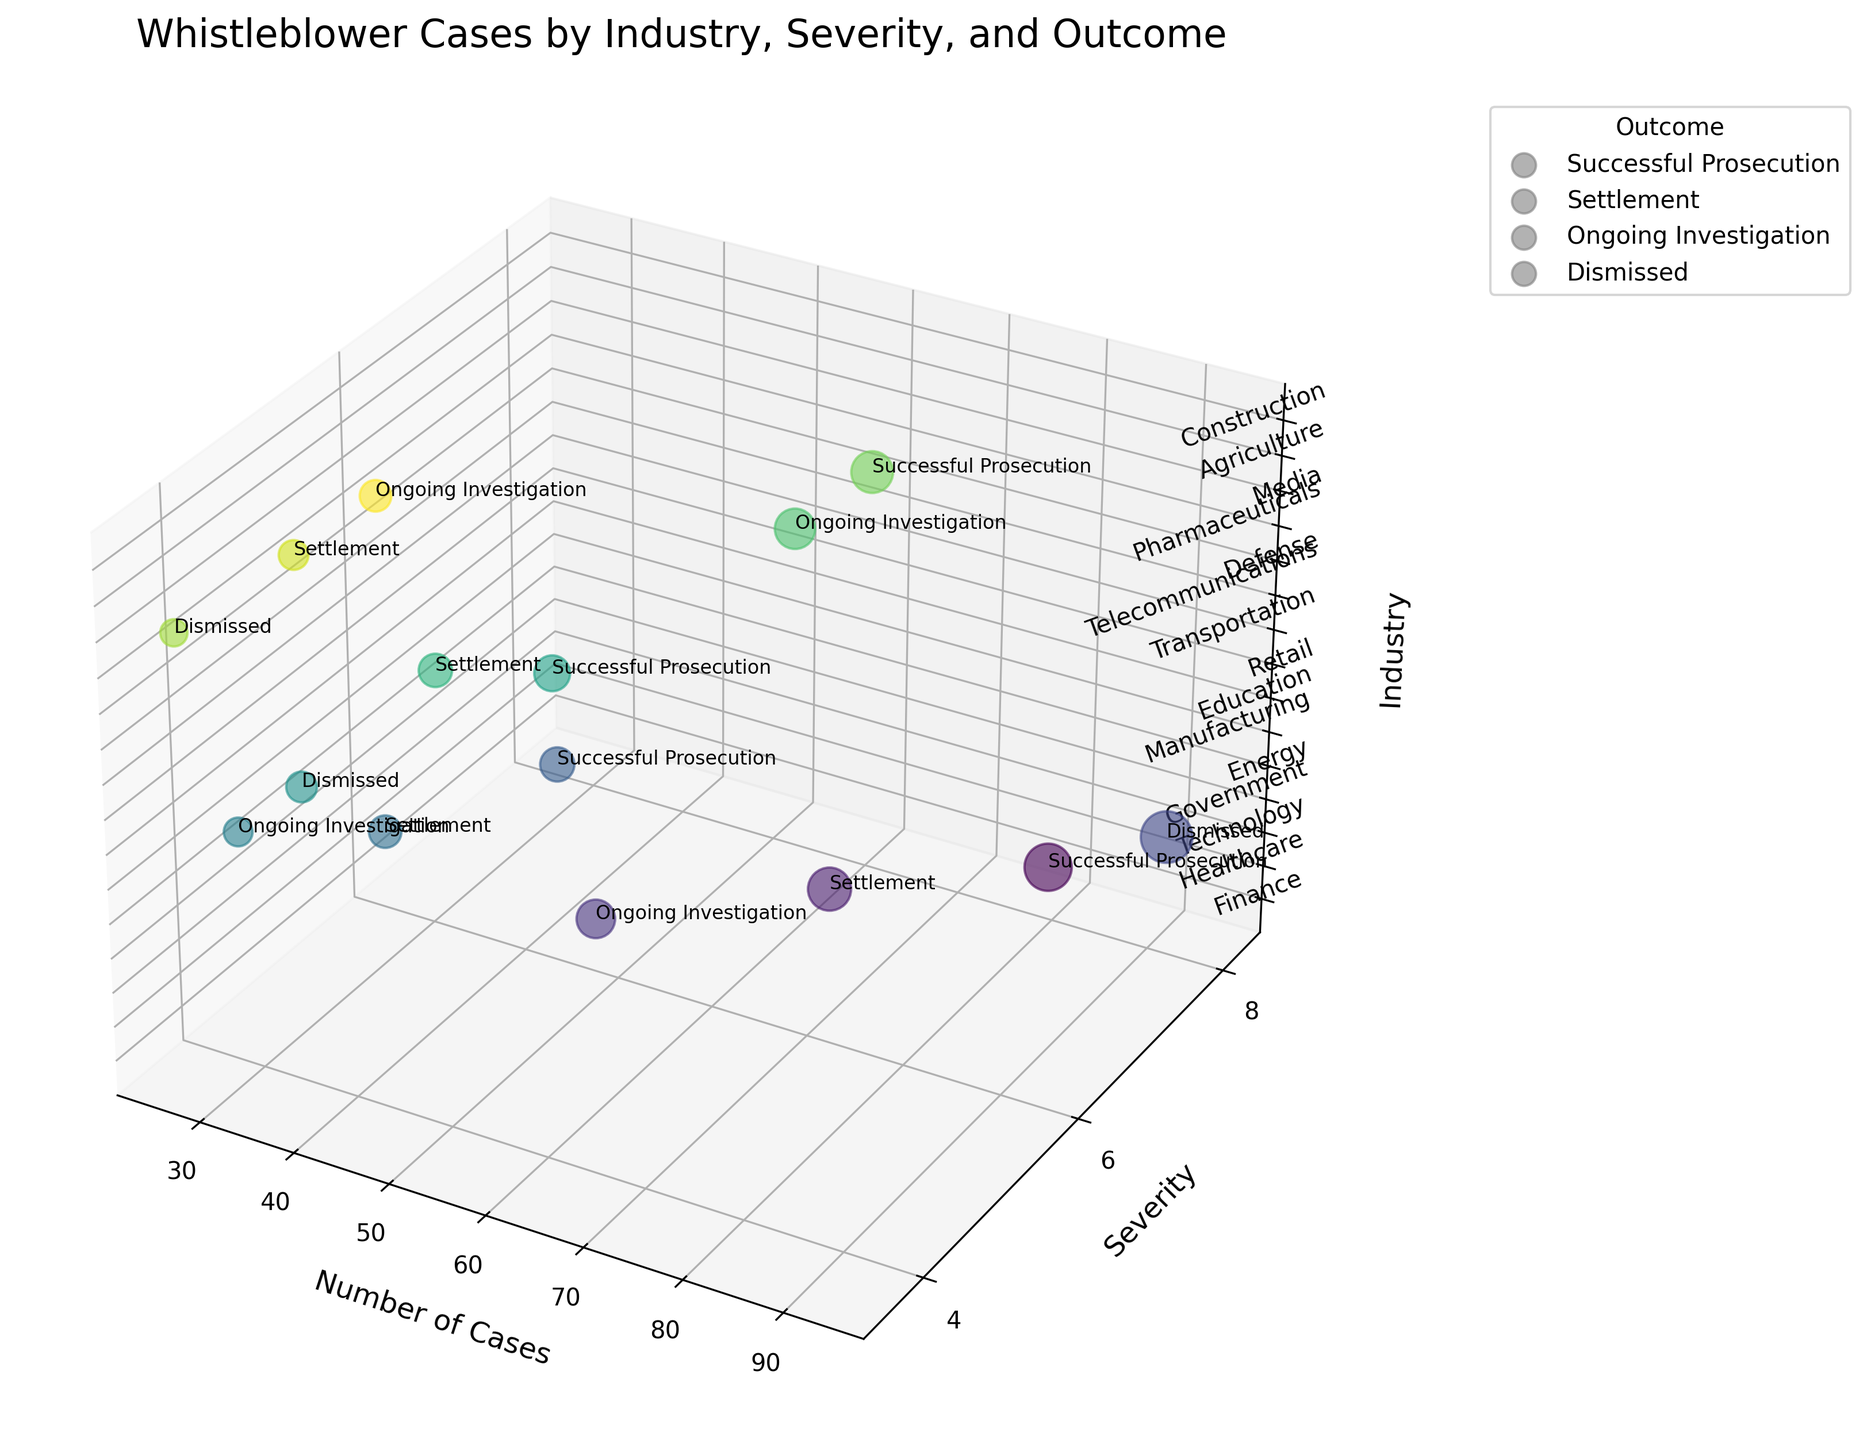What's the title of the figure? The title is displayed at the top of the chart in larger font size
Answer: Whistleblower Cases by Industry, Severity, and Outcome What are the labels of the axes in the figure? The labels of the axes are located next to the axes themselves, indicating what each axis represents
Answer: Number of Cases, Severity, Industry What's the color scheme used for the bubbles in the figure? The colors of the bubbles are derived from the 'viridis' colormap used, which ranges from dark blue to yellow-green
Answer: viridis How many industries are represented in the chart? The number of industries corresponds to the number of bubbles and z-axis ticks in the chart
Answer: 15 Which industry sector has the highest number of cases? The bubbles' size is proportional to the number of cases, and the label displaying the maximum value will indicate this information
Answer: Government What's the outcome of the Transportation sector's whistleblower cases? The labels attached to the bubbles depict the outcome associated with each industry
Answer: Successful Prosecution What's the average severity of the cases in sectors with ongoing investigations? Identify the bubbles labeled 'Ongoing Investigation', sum their severity values, then divide by the number
Answer: (5.5 + 7.4 + 4.9) / 3 = 5.93 Which industry has the largest discrepancy between the severity and the number of cases? Calculate the difference between the severity score and the number of cases for each industry and look for the largest value or notable difference
Answer: Government with 93 cases and a 7.8 severity Compare the outcomes of industries with similar numbers of cases. Look for pairs or groups of bubbles with similar sizes and identify their outcomes, then directly compare them
Answer: Finance and Pharmaceuticals both had high numbers of cases, with successful prosecution Is there a trend between the severity of cases and the number of dismissals? Identify the severity scores for bubbles labeled 'Dismissed' and compare them
Answer: Generally, industries with a lower severity score (3.6-7.8) tend to have more dismissed cases 